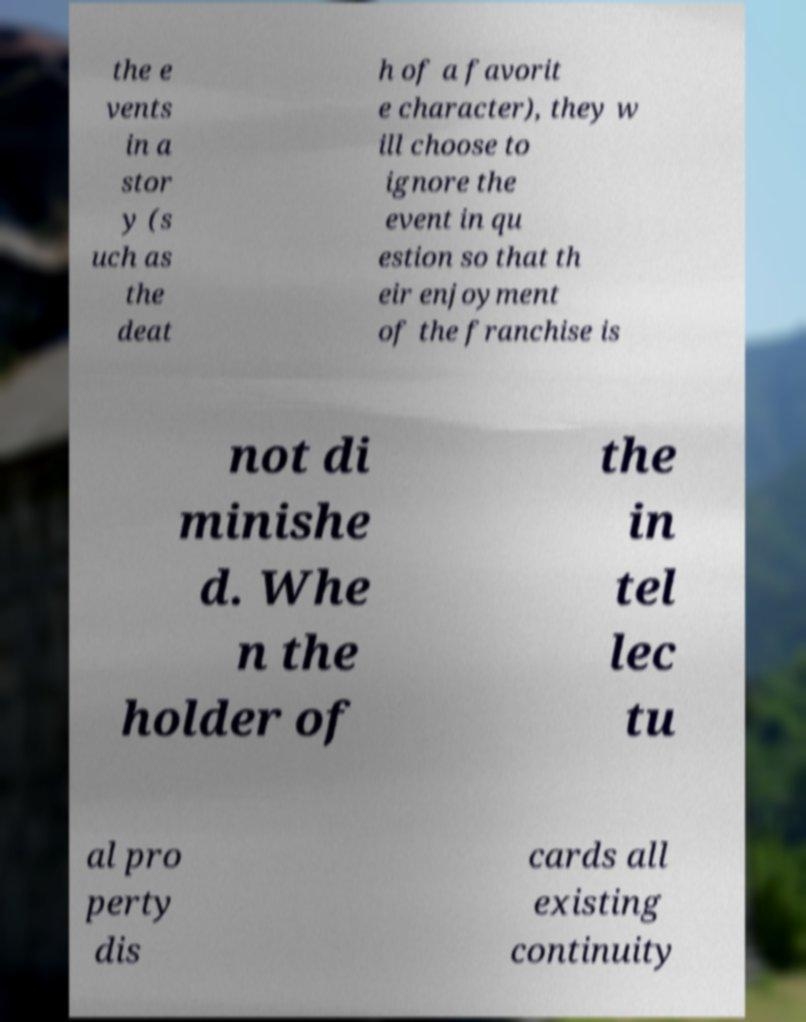What messages or text are displayed in this image? I need them in a readable, typed format. the e vents in a stor y (s uch as the deat h of a favorit e character), they w ill choose to ignore the event in qu estion so that th eir enjoyment of the franchise is not di minishe d. Whe n the holder of the in tel lec tu al pro perty dis cards all existing continuity 